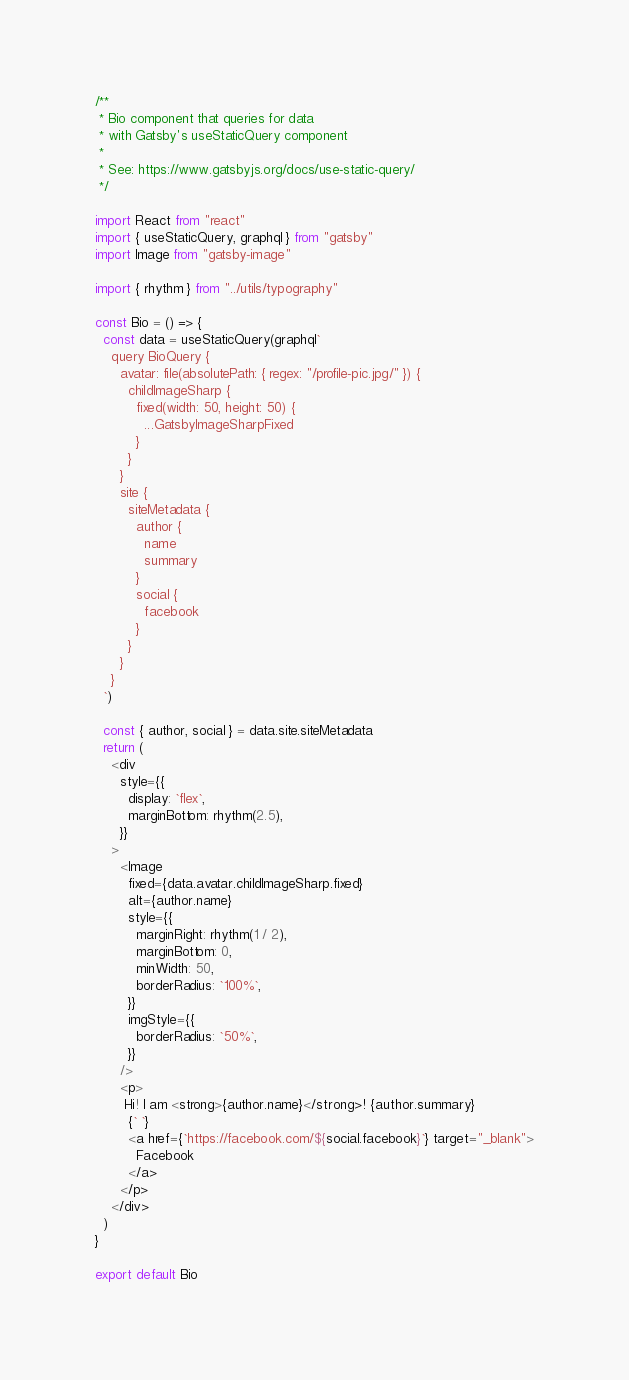<code> <loc_0><loc_0><loc_500><loc_500><_JavaScript_>/**
 * Bio component that queries for data
 * with Gatsby's useStaticQuery component
 *
 * See: https://www.gatsbyjs.org/docs/use-static-query/
 */

import React from "react"
import { useStaticQuery, graphql } from "gatsby"
import Image from "gatsby-image"

import { rhythm } from "../utils/typography"

const Bio = () => {
  const data = useStaticQuery(graphql`
    query BioQuery {
      avatar: file(absolutePath: { regex: "/profile-pic.jpg/" }) {
        childImageSharp {
          fixed(width: 50, height: 50) {
            ...GatsbyImageSharpFixed
          }
        }
      }
      site {
        siteMetadata {
          author {
            name
            summary
          }
          social {
            facebook
          }
        }
      }
    }
  `)

  const { author, social } = data.site.siteMetadata
  return (
    <div
      style={{
        display: `flex`,
        marginBottom: rhythm(2.5),
      }}
    >
      <Image
        fixed={data.avatar.childImageSharp.fixed}
        alt={author.name}
        style={{
          marginRight: rhythm(1 / 2),
          marginBottom: 0,
          minWidth: 50,
          borderRadius: `100%`,
        }}
        imgStyle={{
          borderRadius: `50%`,
        }}
      />
      <p>
       Hi! I am <strong>{author.name}</strong>! {author.summary}
        {` `}
        <a href={`https://facebook.com/${social.facebook}`} target="_blank">
          Facebook
        </a>
      </p>
    </div>
  )
}

export default Bio
</code> 